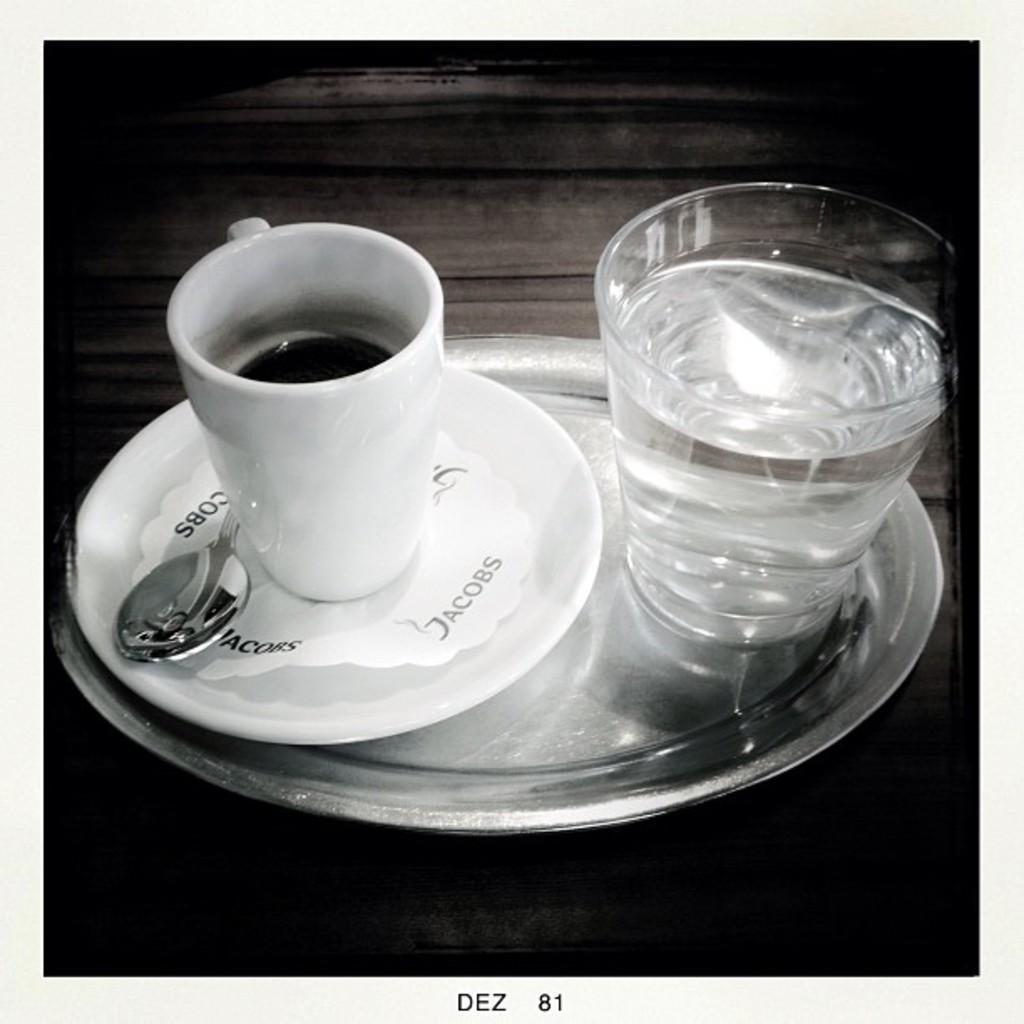What type of container is visible in the image? There is a cup in the image. What else can be seen in the image besides the cup? There is a glass with drinks, a saucer, a spoon, and a plate in the image. Where is the plate located in the image? The plate is on a platform in the image. What type of room is depicted in the image? There is no room depicted in the image; it only shows a cup, a glass with drinks, a saucer, a spoon, and a plate. How much trouble is the spoon causing in the image? There is no indication of trouble caused by the spoon in the image; it is simply a utensil resting on a saucer. 